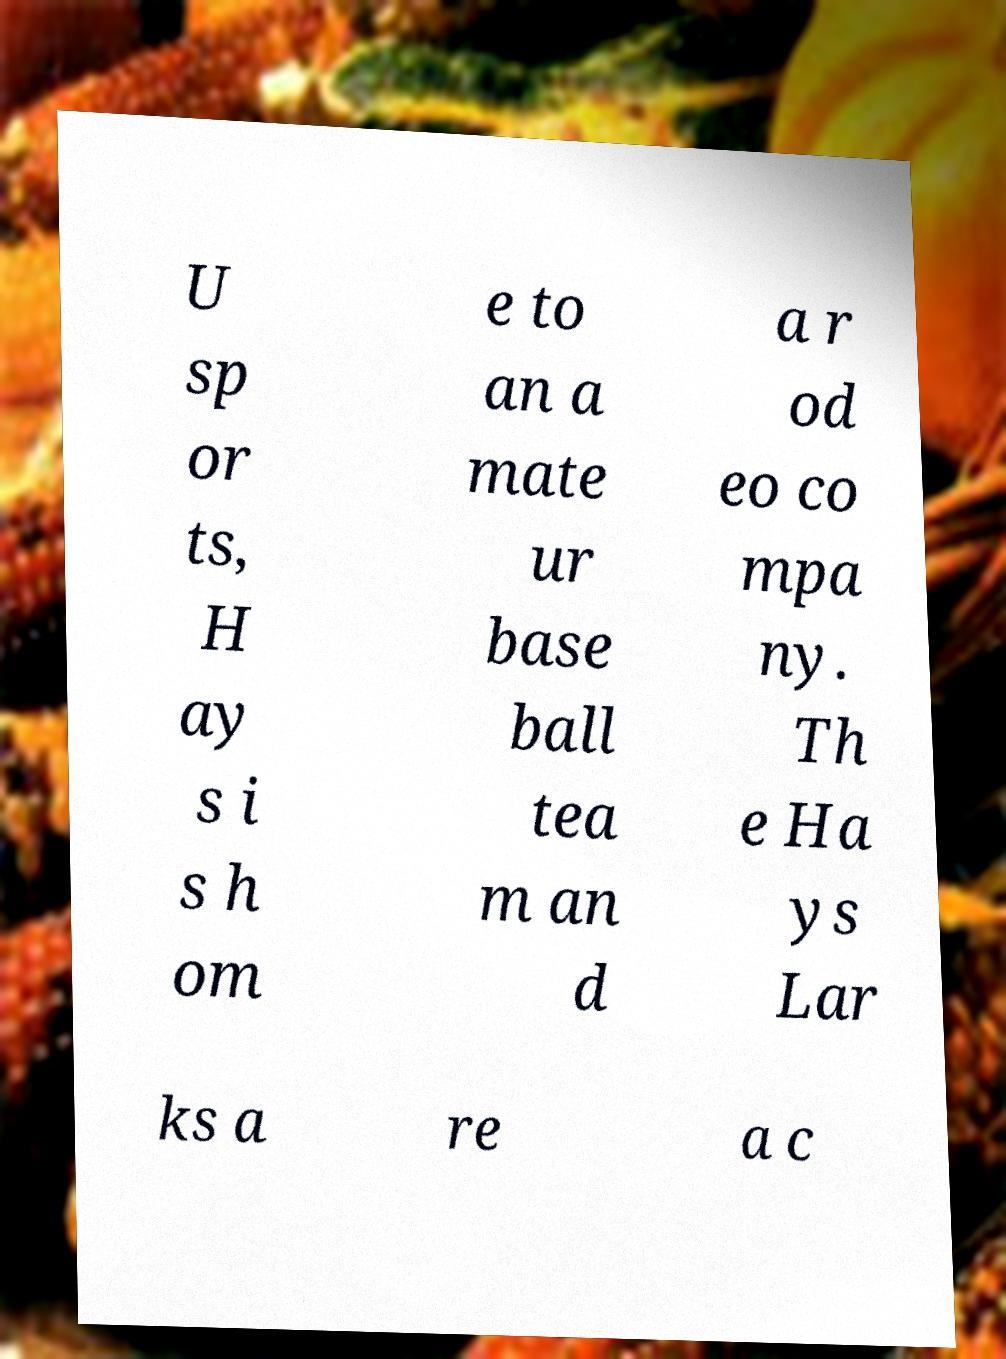Can you accurately transcribe the text from the provided image for me? U sp or ts, H ay s i s h om e to an a mate ur base ball tea m an d a r od eo co mpa ny. Th e Ha ys Lar ks a re a c 